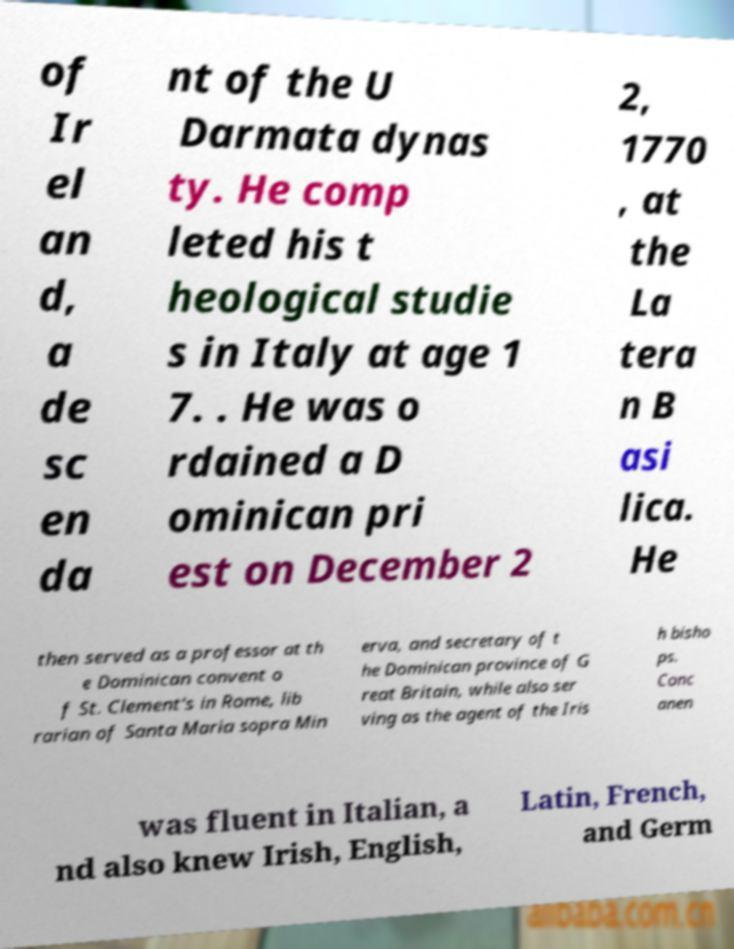There's text embedded in this image that I need extracted. Can you transcribe it verbatim? of Ir el an d, a de sc en da nt of the U Darmata dynas ty. He comp leted his t heological studie s in Italy at age 1 7. . He was o rdained a D ominican pri est on December 2 2, 1770 , at the La tera n B asi lica. He then served as a professor at th e Dominican convent o f St. Clement's in Rome, lib rarian of Santa Maria sopra Min erva, and secretary of t he Dominican province of G reat Britain, while also ser ving as the agent of the Iris h bisho ps. Conc anen was fluent in Italian, a nd also knew Irish, English, Latin, French, and Germ 